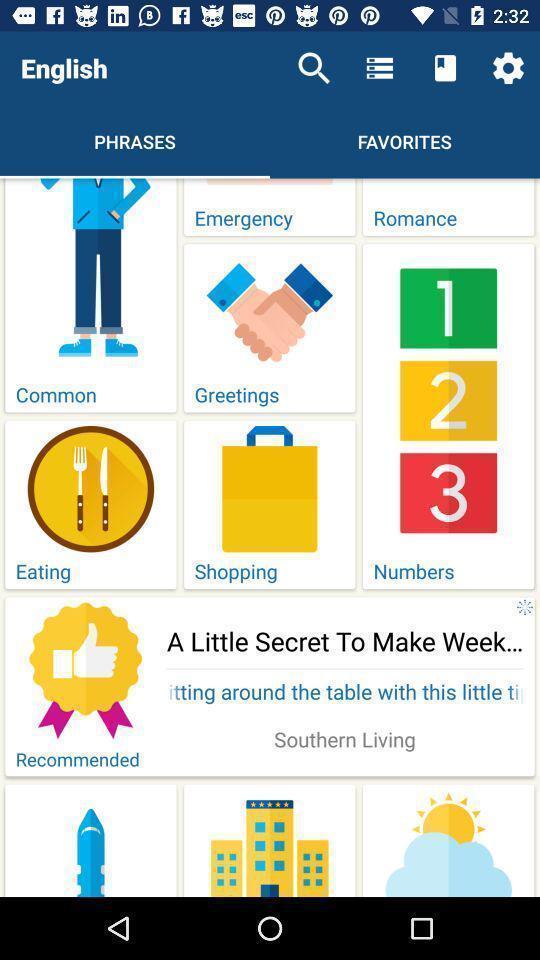What can you discern from this picture? Screen page displaying various categories in learning app. 